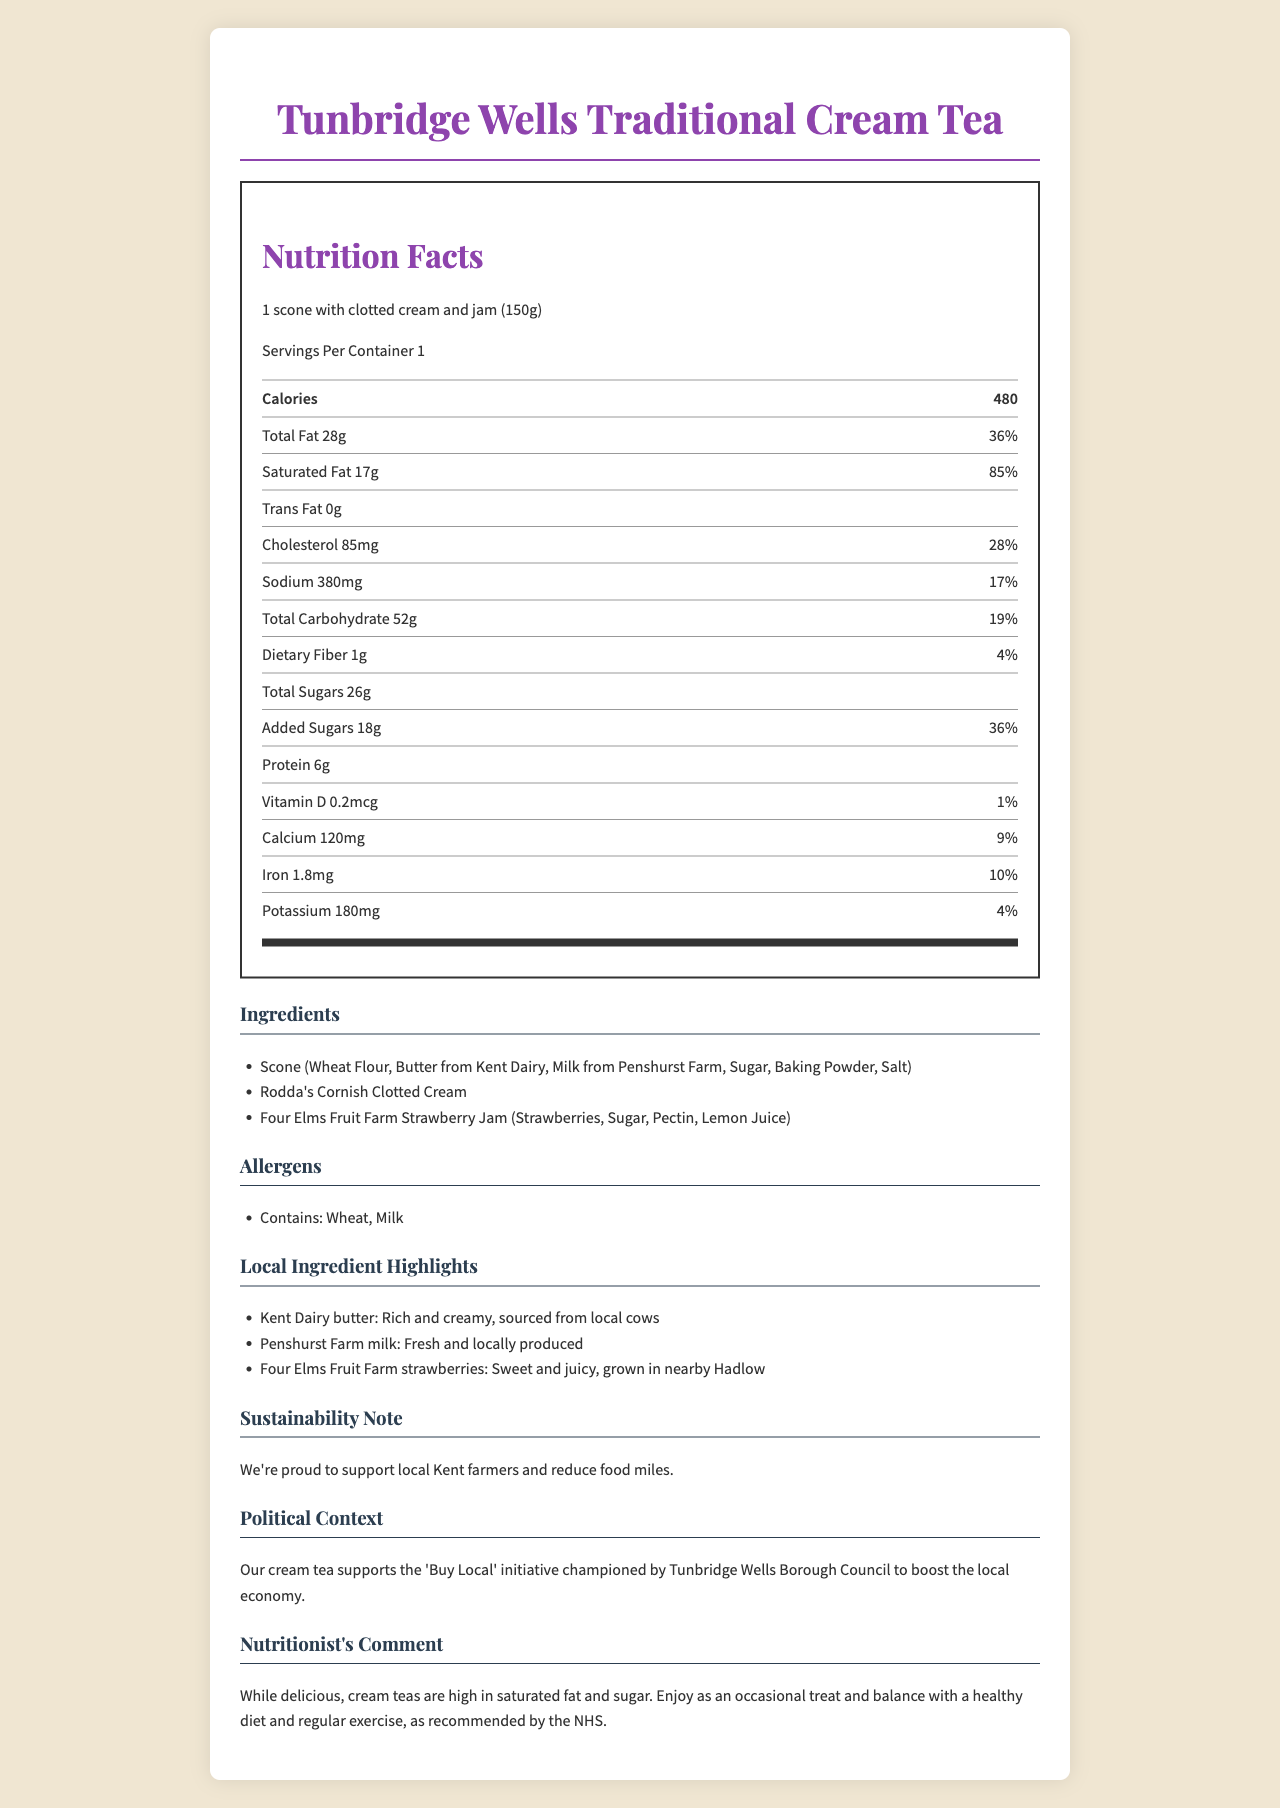what is the serving size for the Tunbridge Wells Traditional Cream Tea? The serving size is directly mentioned at the top of the Nutrition Facts section.
Answer: 1 scone with clotted cream and jam (150g) how many calories are in one serving? The document states that one serving contains 480 calories.
Answer: 480 what is the amount of saturated fat per serving? The Nutrition Facts label shows that there are 17 grams of saturated fat per serving.
Answer: 17g what is the percentage of daily value for iron? According to the Nutrition Facts label, one serving provides 10% of the daily value for iron.
Answer: 10% how much total carbohydrate is in one serving? The document lists the total carbohydrate content as 52 grams per serving.
Answer: 52g which local ingredient is highlighted for its source being Penshurst Farm? The local ingredients section highlights milk from Penshurst Farm as fresh and locally produced.
Answer: Milk what is the main sustainability note in the document? The sustainability note states the product's effort to support local farmers and reduce food miles.
Answer: We're proud to support local Kent farmers and reduce food miles. which organization champions the 'Buy Local' initiative associated with this cream tea? A. UK Government B. Tunbridge Wells Borough Council C. Kent Farmers' Association D. National Farming Union The political context section mentions that the cream tea supports the 'Buy Local' initiative championed by Tunbridge Wells Borough Council.
Answer: B what should consumers balance their intake of traditional cream teas with, according to the nutritionist? A. More cream teas B. A diet rich in fats C. A healthy diet and regular exercise D. More sugary treats The nutritionist comments recommend enjoying cream teas as an occasional treat and balancing them with a healthy diet and regular exercise.
Answer: C does the product contain any trans fat? The Nutrition Facts label states that the product contains 0 grams of trans fat.
Answer: No how much dietary fiber is in one serving? The document shows that there is 1 gram of dietary fiber per serving.
Answer: 1g summarize the main idea of the document. The document details the nutritional content, highlights local ingredient sources, emphasizes sustainability, mentions political support through the 'Buy Local' initiative, and includes a health comment from a nutritionist.
Answer: The document provides nutritional information for the Tunbridge Wells Traditional Cream Tea, highlighting local ingredients from Kent and supporting sustainability efforts. It also includes a nutritionist's comment on consumption. how much protein does one serving contain? The Nutrition Facts label lists the protein content as 6 grams per serving.
Answer: 6g are there any allergens present in the product? The allergens section states that the product contains wheat and milk.
Answer: Yes what is the exact amount of added sugars in one serving? The document states that there are 18 grams of added sugars in one serving.
Answer: 18g what is the relationship with food miles reduction? The document briefly mentions reducing food miles but does not provide detailed information on how this reduction is achieved.
Answer: Not enough information 